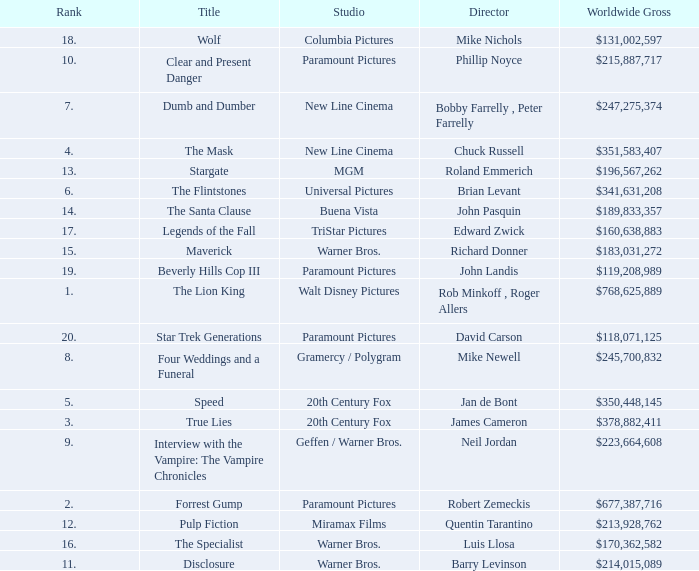Could you help me parse every detail presented in this table? {'header': ['Rank', 'Title', 'Studio', 'Director', 'Worldwide Gross'], 'rows': [['18.', 'Wolf', 'Columbia Pictures', 'Mike Nichols', '$131,002,597'], ['10.', 'Clear and Present Danger', 'Paramount Pictures', 'Phillip Noyce', '$215,887,717'], ['7.', 'Dumb and Dumber', 'New Line Cinema', 'Bobby Farrelly , Peter Farrelly', '$247,275,374'], ['4.', 'The Mask', 'New Line Cinema', 'Chuck Russell', '$351,583,407'], ['13.', 'Stargate', 'MGM', 'Roland Emmerich', '$196,567,262'], ['6.', 'The Flintstones', 'Universal Pictures', 'Brian Levant', '$341,631,208'], ['14.', 'The Santa Clause', 'Buena Vista', 'John Pasquin', '$189,833,357'], ['17.', 'Legends of the Fall', 'TriStar Pictures', 'Edward Zwick', '$160,638,883'], ['15.', 'Maverick', 'Warner Bros.', 'Richard Donner', '$183,031,272'], ['19.', 'Beverly Hills Cop III', 'Paramount Pictures', 'John Landis', '$119,208,989'], ['1.', 'The Lion King', 'Walt Disney Pictures', 'Rob Minkoff , Roger Allers', '$768,625,889'], ['20.', 'Star Trek Generations', 'Paramount Pictures', 'David Carson', '$118,071,125'], ['8.', 'Four Weddings and a Funeral', 'Gramercy / Polygram', 'Mike Newell', '$245,700,832'], ['5.', 'Speed', '20th Century Fox', 'Jan de Bont', '$350,448,145'], ['3.', 'True Lies', '20th Century Fox', 'James Cameron', '$378,882,411'], ['9.', 'Interview with the Vampire: The Vampire Chronicles', 'Geffen / Warner Bros.', 'Neil Jordan', '$223,664,608'], ['2.', 'Forrest Gump', 'Paramount Pictures', 'Robert Zemeckis', '$677,387,716'], ['12.', 'Pulp Fiction', 'Miramax Films', 'Quentin Tarantino', '$213,928,762'], ['16.', 'The Specialist', 'Warner Bros.', 'Luis Llosa', '$170,362,582'], ['11.', 'Disclosure', 'Warner Bros.', 'Barry Levinson', '$214,015,089']]} What is the Rank of the Film with a Worldwide Gross of $183,031,272? 15.0. 